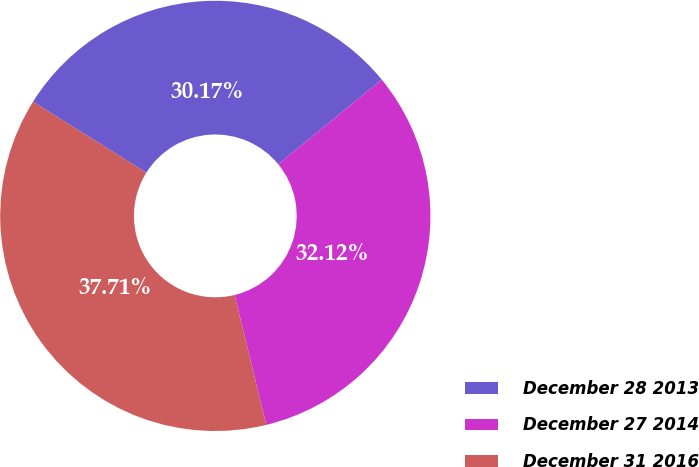<chart> <loc_0><loc_0><loc_500><loc_500><pie_chart><fcel>December 28 2013<fcel>December 27 2014<fcel>December 31 2016<nl><fcel>30.17%<fcel>32.12%<fcel>37.71%<nl></chart> 